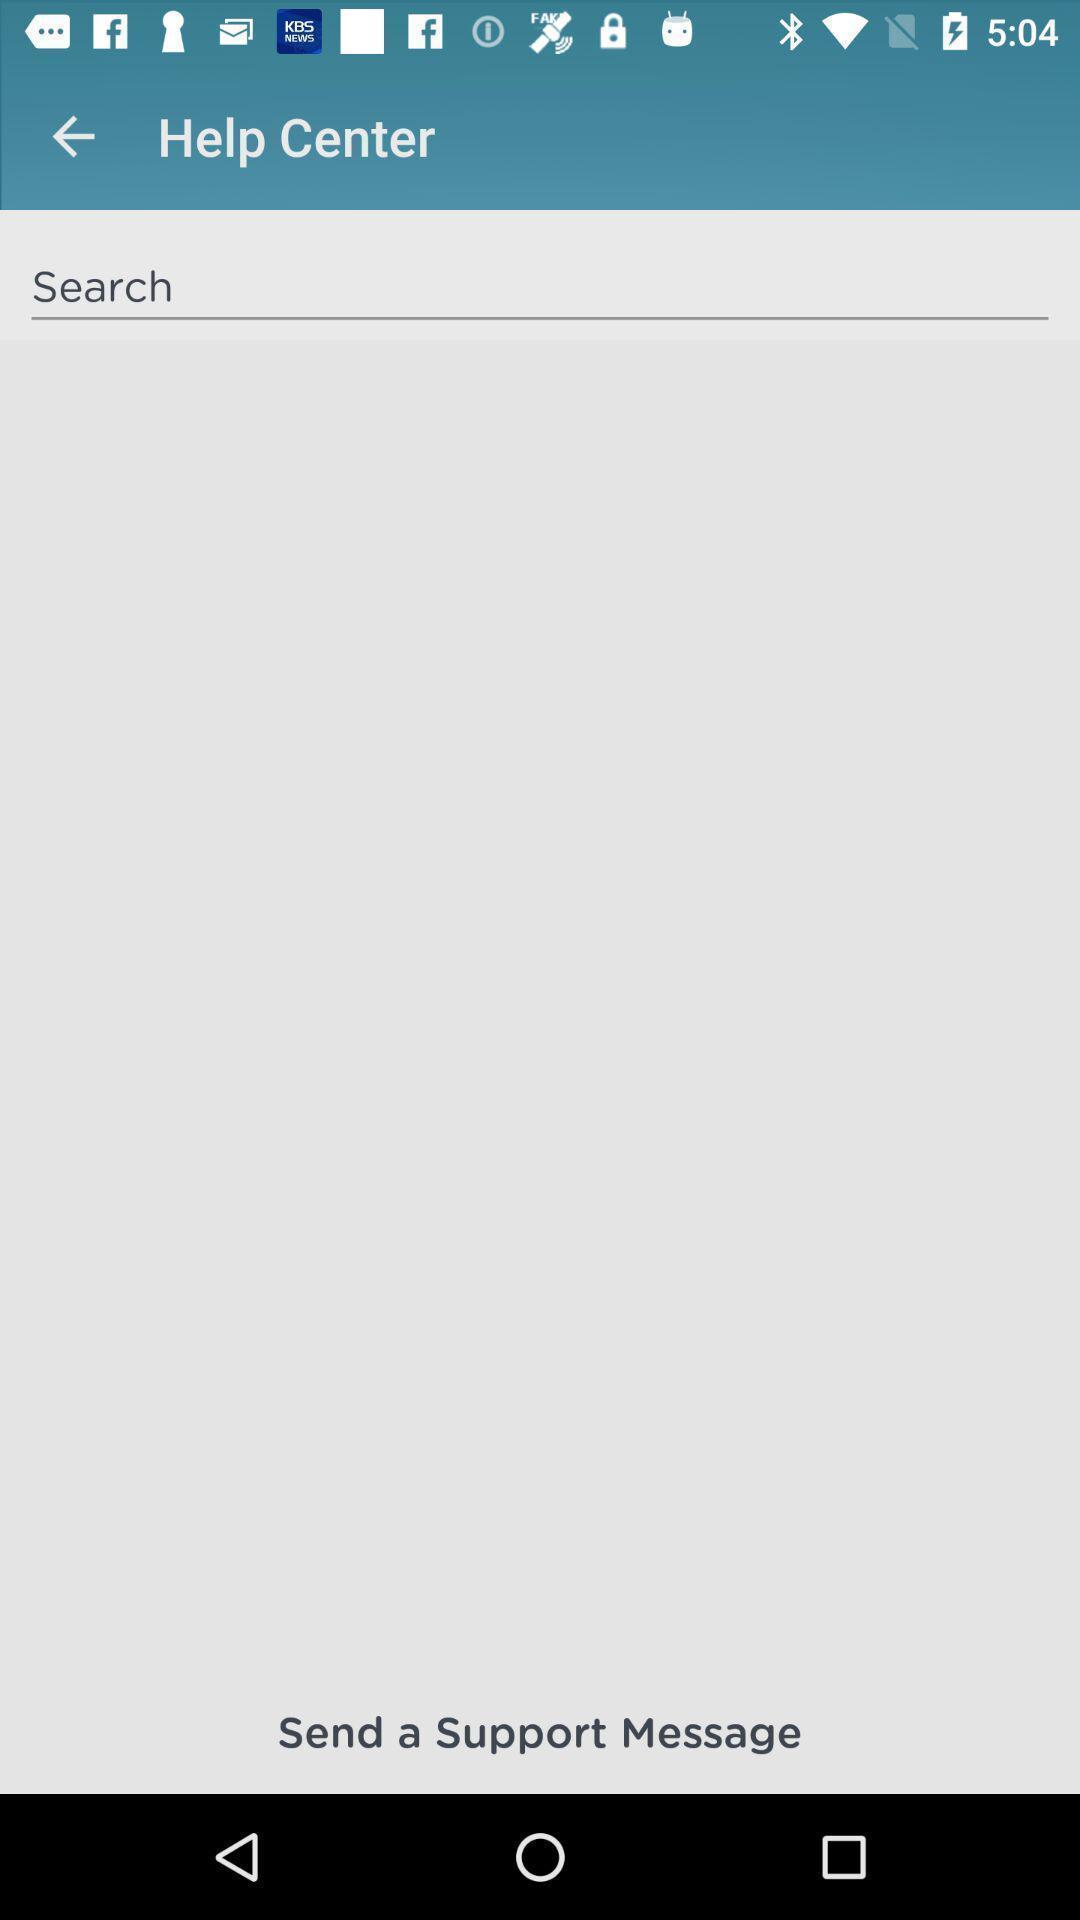Provide a textual representation of this image. Screen displaying the help center page. 